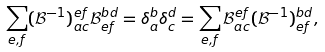Convert formula to latex. <formula><loc_0><loc_0><loc_500><loc_500>\sum _ { e , f } ( \mathcal { B } ^ { - 1 } ) ^ { e f } _ { a c } \mathcal { B } ^ { b d } _ { e f } = \delta _ { a } ^ { b } \delta _ { c } ^ { d } = \sum _ { e , f } \mathcal { B } ^ { e f } _ { a c } ( \mathcal { B } ^ { - 1 } ) ^ { b d } _ { e f } ,</formula> 